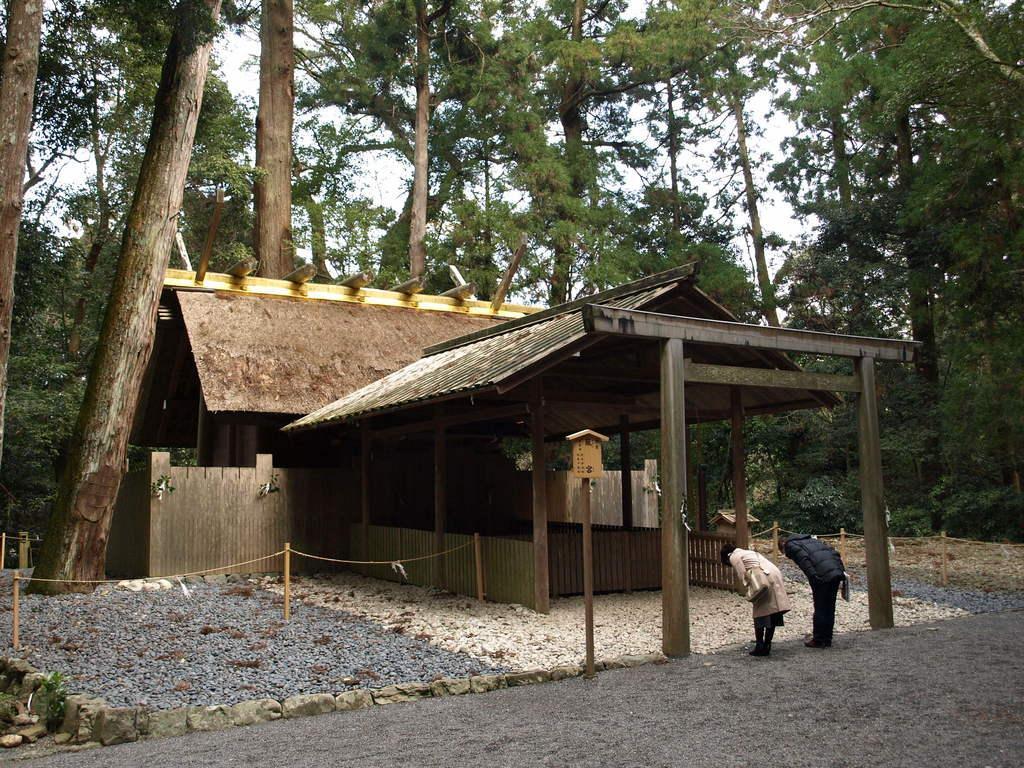Please provide a concise description of this image. In the image we can see there are two people wearing clothes and shoes, this is a handbag, and, stones, chain, pole, trees and a sky. This is a house. 